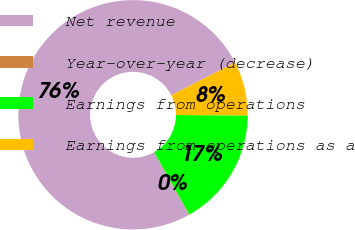Convert chart to OTSL. <chart><loc_0><loc_0><loc_500><loc_500><pie_chart><fcel>Net revenue<fcel>Year-over-year (decrease)<fcel>Earnings from operations<fcel>Earnings from operations as a<nl><fcel>75.58%<fcel>0.07%<fcel>16.73%<fcel>7.62%<nl></chart> 